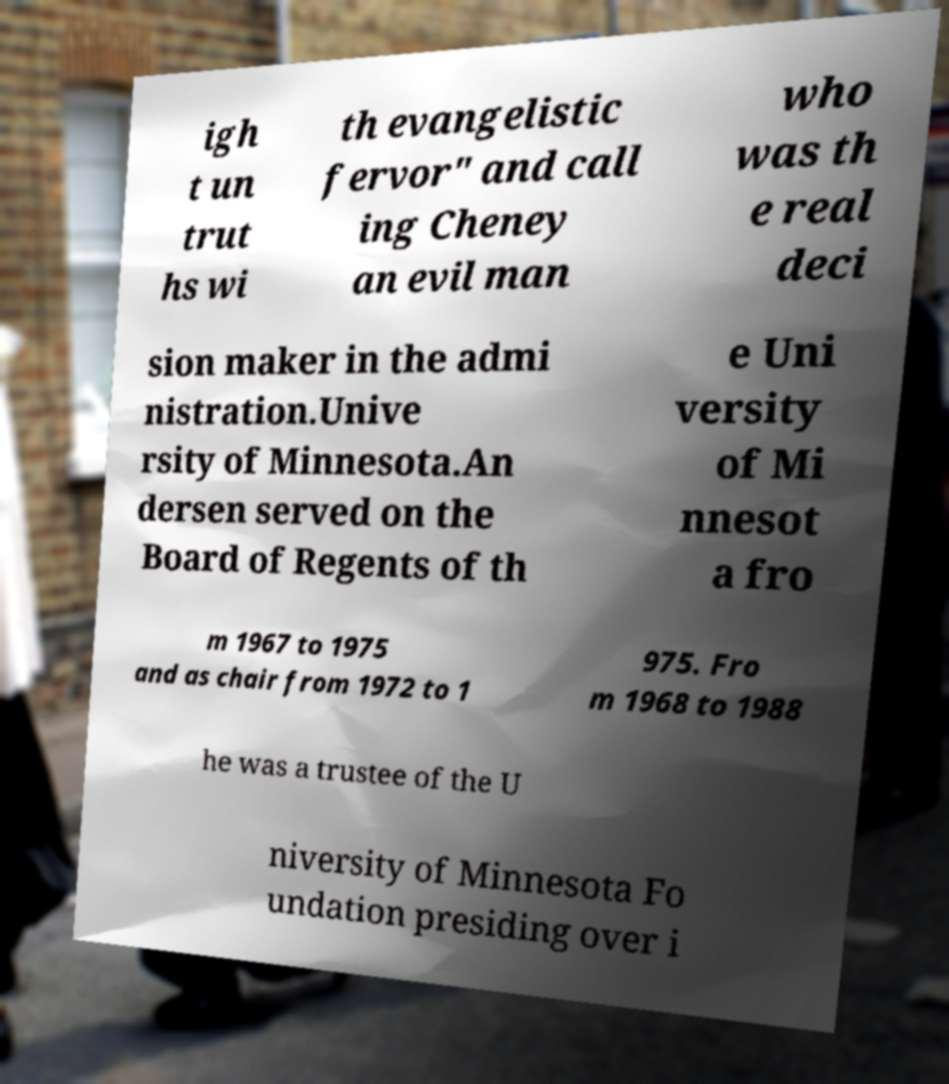Could you assist in decoding the text presented in this image and type it out clearly? igh t un trut hs wi th evangelistic fervor" and call ing Cheney an evil man who was th e real deci sion maker in the admi nistration.Unive rsity of Minnesota.An dersen served on the Board of Regents of th e Uni versity of Mi nnesot a fro m 1967 to 1975 and as chair from 1972 to 1 975. Fro m 1968 to 1988 he was a trustee of the U niversity of Minnesota Fo undation presiding over i 